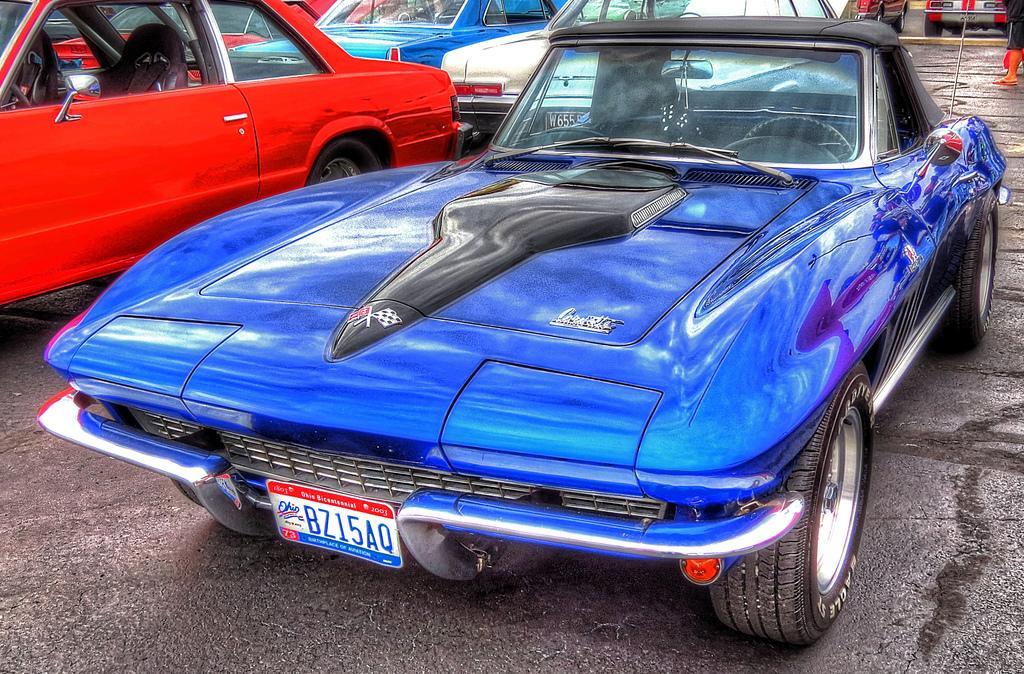How would you summarize this image in a sentence or two? In the picture I can see cars on the ground. The car in the front is blue in color. In the background I can see some objects on the ground. 